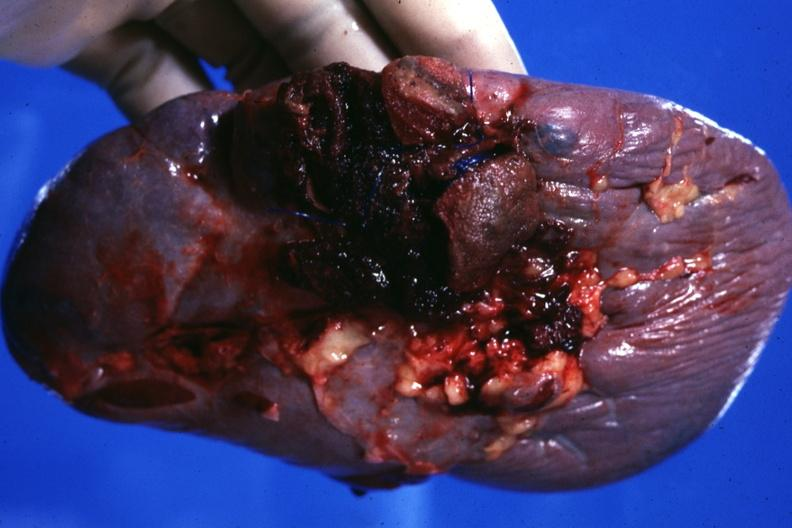s lymphangiomatosis generalized present?
Answer the question using a single word or phrase. No 